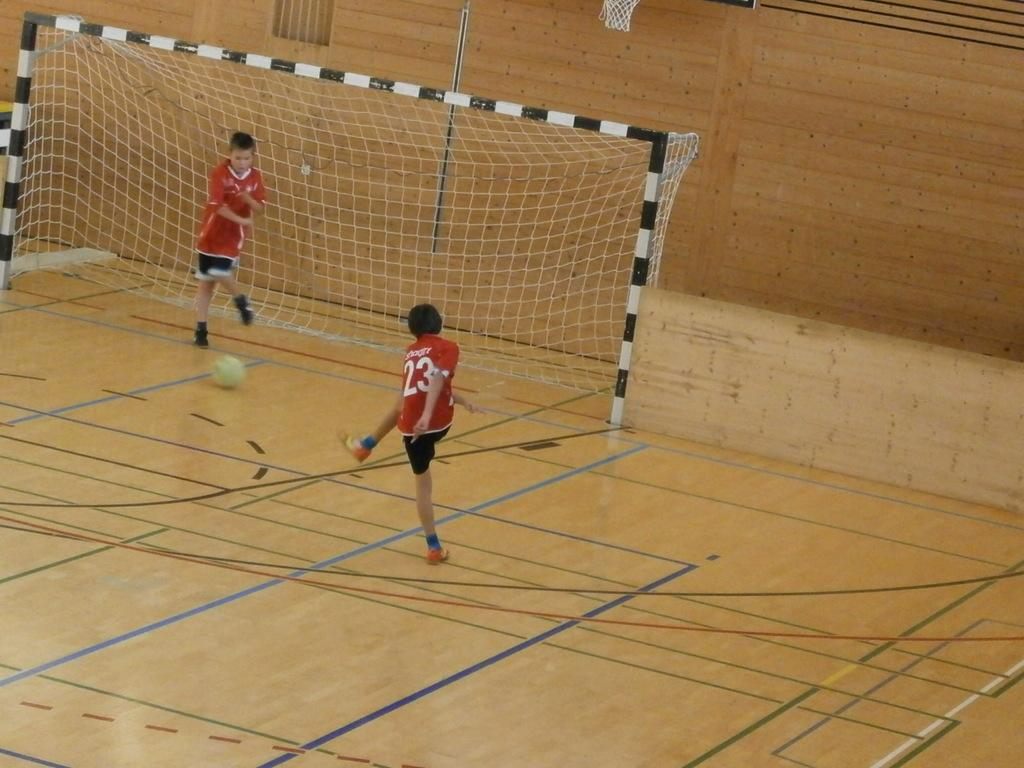What are the two people in the image doing? The two people in the image are playing football. Where is the football game taking place? The football game is taking place on the floor. What object is central to the game? There is a ball in the image. What structure is present in the image? There is a net with rods in the image. What can be seen in the background of the image? There is a wall in the background of the image. How many stamps are on the football in the image? There are no stamps on the football in the image. Can you see any sheep in the image? There are no sheep present in the image. 